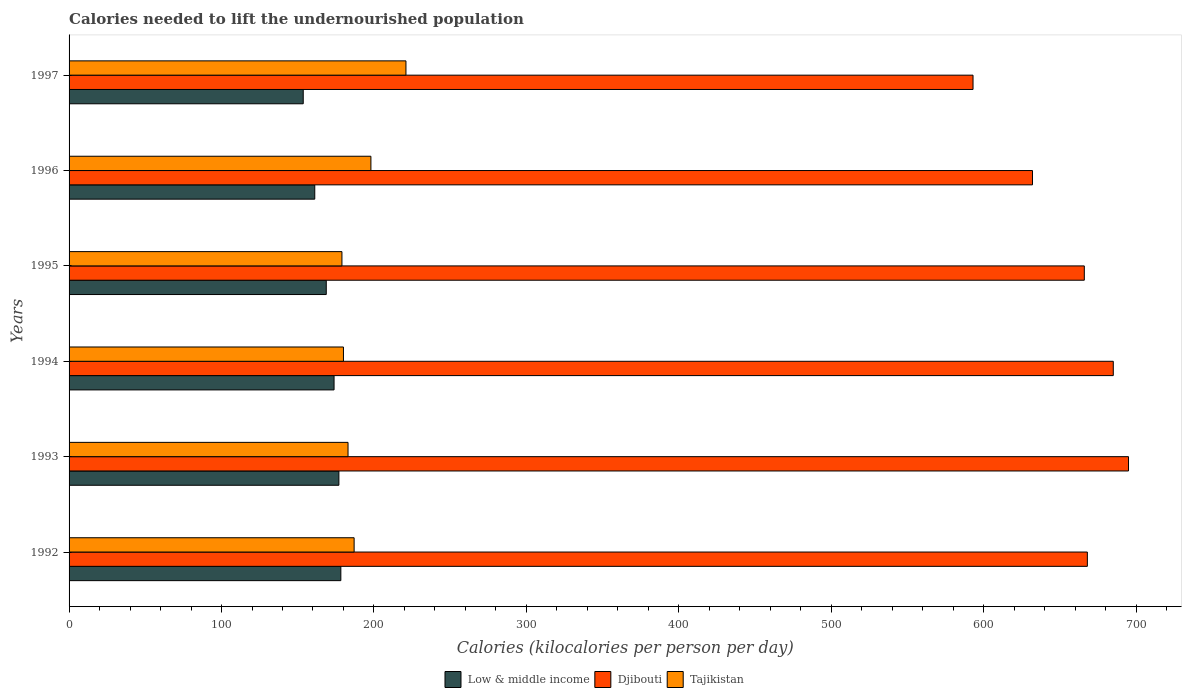How many different coloured bars are there?
Give a very brief answer. 3. How many groups of bars are there?
Your answer should be very brief. 6. What is the label of the 2nd group of bars from the top?
Provide a succinct answer. 1996. In how many cases, is the number of bars for a given year not equal to the number of legend labels?
Your response must be concise. 0. What is the total calories needed to lift the undernourished population in Low & middle income in 1995?
Keep it short and to the point. 168.72. Across all years, what is the maximum total calories needed to lift the undernourished population in Low & middle income?
Your answer should be very brief. 178.28. Across all years, what is the minimum total calories needed to lift the undernourished population in Low & middle income?
Make the answer very short. 153.61. In which year was the total calories needed to lift the undernourished population in Tajikistan minimum?
Offer a very short reply. 1995. What is the total total calories needed to lift the undernourished population in Djibouti in the graph?
Provide a succinct answer. 3939. What is the difference between the total calories needed to lift the undernourished population in Djibouti in 1992 and that in 1995?
Your answer should be compact. 2. What is the difference between the total calories needed to lift the undernourished population in Tajikistan in 1994 and the total calories needed to lift the undernourished population in Low & middle income in 1992?
Your answer should be very brief. 1.72. What is the average total calories needed to lift the undernourished population in Low & middle income per year?
Your answer should be very brief. 168.77. In the year 1996, what is the difference between the total calories needed to lift the undernourished population in Tajikistan and total calories needed to lift the undernourished population in Djibouti?
Make the answer very short. -434. In how many years, is the total calories needed to lift the undernourished population in Tajikistan greater than 500 kilocalories?
Give a very brief answer. 0. What is the ratio of the total calories needed to lift the undernourished population in Low & middle income in 1992 to that in 1993?
Keep it short and to the point. 1.01. Is the total calories needed to lift the undernourished population in Low & middle income in 1994 less than that in 1996?
Offer a very short reply. No. Is the difference between the total calories needed to lift the undernourished population in Tajikistan in 1994 and 1996 greater than the difference between the total calories needed to lift the undernourished population in Djibouti in 1994 and 1996?
Ensure brevity in your answer.  No. What is the difference between the highest and the lowest total calories needed to lift the undernourished population in Low & middle income?
Your answer should be compact. 24.67. What does the 1st bar from the top in 1994 represents?
Make the answer very short. Tajikistan. What does the 3rd bar from the bottom in 1996 represents?
Your answer should be compact. Tajikistan. Is it the case that in every year, the sum of the total calories needed to lift the undernourished population in Tajikistan and total calories needed to lift the undernourished population in Djibouti is greater than the total calories needed to lift the undernourished population in Low & middle income?
Offer a terse response. Yes. How many bars are there?
Offer a terse response. 18. Are all the bars in the graph horizontal?
Ensure brevity in your answer.  Yes. How many years are there in the graph?
Provide a succinct answer. 6. What is the difference between two consecutive major ticks on the X-axis?
Keep it short and to the point. 100. Are the values on the major ticks of X-axis written in scientific E-notation?
Keep it short and to the point. No. Does the graph contain any zero values?
Keep it short and to the point. No. Does the graph contain grids?
Offer a terse response. No. What is the title of the graph?
Offer a very short reply. Calories needed to lift the undernourished population. What is the label or title of the X-axis?
Your answer should be compact. Calories (kilocalories per person per day). What is the label or title of the Y-axis?
Your answer should be compact. Years. What is the Calories (kilocalories per person per day) of Low & middle income in 1992?
Keep it short and to the point. 178.28. What is the Calories (kilocalories per person per day) in Djibouti in 1992?
Your answer should be compact. 668. What is the Calories (kilocalories per person per day) in Tajikistan in 1992?
Your answer should be very brief. 187. What is the Calories (kilocalories per person per day) of Low & middle income in 1993?
Give a very brief answer. 177. What is the Calories (kilocalories per person per day) in Djibouti in 1993?
Keep it short and to the point. 695. What is the Calories (kilocalories per person per day) of Tajikistan in 1993?
Your answer should be very brief. 183. What is the Calories (kilocalories per person per day) of Low & middle income in 1994?
Offer a terse response. 173.84. What is the Calories (kilocalories per person per day) of Djibouti in 1994?
Your response must be concise. 685. What is the Calories (kilocalories per person per day) of Tajikistan in 1994?
Offer a terse response. 180. What is the Calories (kilocalories per person per day) in Low & middle income in 1995?
Make the answer very short. 168.72. What is the Calories (kilocalories per person per day) of Djibouti in 1995?
Your answer should be very brief. 666. What is the Calories (kilocalories per person per day) of Tajikistan in 1995?
Provide a succinct answer. 179. What is the Calories (kilocalories per person per day) of Low & middle income in 1996?
Ensure brevity in your answer.  161.17. What is the Calories (kilocalories per person per day) in Djibouti in 1996?
Your answer should be very brief. 632. What is the Calories (kilocalories per person per day) of Tajikistan in 1996?
Provide a succinct answer. 198. What is the Calories (kilocalories per person per day) of Low & middle income in 1997?
Your answer should be compact. 153.61. What is the Calories (kilocalories per person per day) in Djibouti in 1997?
Offer a very short reply. 593. What is the Calories (kilocalories per person per day) in Tajikistan in 1997?
Keep it short and to the point. 221. Across all years, what is the maximum Calories (kilocalories per person per day) of Low & middle income?
Your response must be concise. 178.28. Across all years, what is the maximum Calories (kilocalories per person per day) in Djibouti?
Offer a very short reply. 695. Across all years, what is the maximum Calories (kilocalories per person per day) in Tajikistan?
Keep it short and to the point. 221. Across all years, what is the minimum Calories (kilocalories per person per day) in Low & middle income?
Keep it short and to the point. 153.61. Across all years, what is the minimum Calories (kilocalories per person per day) of Djibouti?
Provide a short and direct response. 593. Across all years, what is the minimum Calories (kilocalories per person per day) of Tajikistan?
Your answer should be compact. 179. What is the total Calories (kilocalories per person per day) of Low & middle income in the graph?
Your answer should be compact. 1012.62. What is the total Calories (kilocalories per person per day) in Djibouti in the graph?
Keep it short and to the point. 3939. What is the total Calories (kilocalories per person per day) in Tajikistan in the graph?
Offer a very short reply. 1148. What is the difference between the Calories (kilocalories per person per day) of Low & middle income in 1992 and that in 1993?
Your answer should be compact. 1.28. What is the difference between the Calories (kilocalories per person per day) of Djibouti in 1992 and that in 1993?
Ensure brevity in your answer.  -27. What is the difference between the Calories (kilocalories per person per day) in Low & middle income in 1992 and that in 1994?
Provide a short and direct response. 4.44. What is the difference between the Calories (kilocalories per person per day) of Tajikistan in 1992 and that in 1994?
Provide a short and direct response. 7. What is the difference between the Calories (kilocalories per person per day) of Low & middle income in 1992 and that in 1995?
Keep it short and to the point. 9.56. What is the difference between the Calories (kilocalories per person per day) in Low & middle income in 1992 and that in 1996?
Offer a terse response. 17.11. What is the difference between the Calories (kilocalories per person per day) in Low & middle income in 1992 and that in 1997?
Ensure brevity in your answer.  24.67. What is the difference between the Calories (kilocalories per person per day) of Djibouti in 1992 and that in 1997?
Provide a succinct answer. 75. What is the difference between the Calories (kilocalories per person per day) in Tajikistan in 1992 and that in 1997?
Ensure brevity in your answer.  -34. What is the difference between the Calories (kilocalories per person per day) in Low & middle income in 1993 and that in 1994?
Your answer should be very brief. 3.16. What is the difference between the Calories (kilocalories per person per day) in Low & middle income in 1993 and that in 1995?
Provide a short and direct response. 8.28. What is the difference between the Calories (kilocalories per person per day) of Djibouti in 1993 and that in 1995?
Offer a terse response. 29. What is the difference between the Calories (kilocalories per person per day) of Tajikistan in 1993 and that in 1995?
Provide a short and direct response. 4. What is the difference between the Calories (kilocalories per person per day) of Low & middle income in 1993 and that in 1996?
Provide a short and direct response. 15.83. What is the difference between the Calories (kilocalories per person per day) of Tajikistan in 1993 and that in 1996?
Keep it short and to the point. -15. What is the difference between the Calories (kilocalories per person per day) in Low & middle income in 1993 and that in 1997?
Your answer should be very brief. 23.39. What is the difference between the Calories (kilocalories per person per day) in Djibouti in 1993 and that in 1997?
Your response must be concise. 102. What is the difference between the Calories (kilocalories per person per day) in Tajikistan in 1993 and that in 1997?
Your response must be concise. -38. What is the difference between the Calories (kilocalories per person per day) in Low & middle income in 1994 and that in 1995?
Offer a terse response. 5.12. What is the difference between the Calories (kilocalories per person per day) in Tajikistan in 1994 and that in 1995?
Keep it short and to the point. 1. What is the difference between the Calories (kilocalories per person per day) in Low & middle income in 1994 and that in 1996?
Provide a succinct answer. 12.66. What is the difference between the Calories (kilocalories per person per day) of Tajikistan in 1994 and that in 1996?
Ensure brevity in your answer.  -18. What is the difference between the Calories (kilocalories per person per day) in Low & middle income in 1994 and that in 1997?
Make the answer very short. 20.23. What is the difference between the Calories (kilocalories per person per day) of Djibouti in 1994 and that in 1997?
Keep it short and to the point. 92. What is the difference between the Calories (kilocalories per person per day) in Tajikistan in 1994 and that in 1997?
Provide a short and direct response. -41. What is the difference between the Calories (kilocalories per person per day) of Low & middle income in 1995 and that in 1996?
Offer a very short reply. 7.55. What is the difference between the Calories (kilocalories per person per day) in Djibouti in 1995 and that in 1996?
Keep it short and to the point. 34. What is the difference between the Calories (kilocalories per person per day) in Low & middle income in 1995 and that in 1997?
Ensure brevity in your answer.  15.11. What is the difference between the Calories (kilocalories per person per day) in Tajikistan in 1995 and that in 1997?
Offer a very short reply. -42. What is the difference between the Calories (kilocalories per person per day) of Low & middle income in 1996 and that in 1997?
Give a very brief answer. 7.57. What is the difference between the Calories (kilocalories per person per day) in Low & middle income in 1992 and the Calories (kilocalories per person per day) in Djibouti in 1993?
Offer a terse response. -516.72. What is the difference between the Calories (kilocalories per person per day) in Low & middle income in 1992 and the Calories (kilocalories per person per day) in Tajikistan in 1993?
Ensure brevity in your answer.  -4.72. What is the difference between the Calories (kilocalories per person per day) of Djibouti in 1992 and the Calories (kilocalories per person per day) of Tajikistan in 1993?
Your answer should be compact. 485. What is the difference between the Calories (kilocalories per person per day) in Low & middle income in 1992 and the Calories (kilocalories per person per day) in Djibouti in 1994?
Offer a very short reply. -506.72. What is the difference between the Calories (kilocalories per person per day) of Low & middle income in 1992 and the Calories (kilocalories per person per day) of Tajikistan in 1994?
Keep it short and to the point. -1.72. What is the difference between the Calories (kilocalories per person per day) of Djibouti in 1992 and the Calories (kilocalories per person per day) of Tajikistan in 1994?
Provide a short and direct response. 488. What is the difference between the Calories (kilocalories per person per day) in Low & middle income in 1992 and the Calories (kilocalories per person per day) in Djibouti in 1995?
Ensure brevity in your answer.  -487.72. What is the difference between the Calories (kilocalories per person per day) in Low & middle income in 1992 and the Calories (kilocalories per person per day) in Tajikistan in 1995?
Make the answer very short. -0.72. What is the difference between the Calories (kilocalories per person per day) in Djibouti in 1992 and the Calories (kilocalories per person per day) in Tajikistan in 1995?
Your answer should be very brief. 489. What is the difference between the Calories (kilocalories per person per day) in Low & middle income in 1992 and the Calories (kilocalories per person per day) in Djibouti in 1996?
Your response must be concise. -453.72. What is the difference between the Calories (kilocalories per person per day) of Low & middle income in 1992 and the Calories (kilocalories per person per day) of Tajikistan in 1996?
Ensure brevity in your answer.  -19.72. What is the difference between the Calories (kilocalories per person per day) in Djibouti in 1992 and the Calories (kilocalories per person per day) in Tajikistan in 1996?
Provide a succinct answer. 470. What is the difference between the Calories (kilocalories per person per day) in Low & middle income in 1992 and the Calories (kilocalories per person per day) in Djibouti in 1997?
Your response must be concise. -414.72. What is the difference between the Calories (kilocalories per person per day) in Low & middle income in 1992 and the Calories (kilocalories per person per day) in Tajikistan in 1997?
Give a very brief answer. -42.72. What is the difference between the Calories (kilocalories per person per day) in Djibouti in 1992 and the Calories (kilocalories per person per day) in Tajikistan in 1997?
Your answer should be very brief. 447. What is the difference between the Calories (kilocalories per person per day) in Low & middle income in 1993 and the Calories (kilocalories per person per day) in Djibouti in 1994?
Keep it short and to the point. -508. What is the difference between the Calories (kilocalories per person per day) of Low & middle income in 1993 and the Calories (kilocalories per person per day) of Tajikistan in 1994?
Provide a succinct answer. -3. What is the difference between the Calories (kilocalories per person per day) in Djibouti in 1993 and the Calories (kilocalories per person per day) in Tajikistan in 1994?
Make the answer very short. 515. What is the difference between the Calories (kilocalories per person per day) of Low & middle income in 1993 and the Calories (kilocalories per person per day) of Djibouti in 1995?
Your response must be concise. -489. What is the difference between the Calories (kilocalories per person per day) in Low & middle income in 1993 and the Calories (kilocalories per person per day) in Tajikistan in 1995?
Offer a terse response. -2. What is the difference between the Calories (kilocalories per person per day) in Djibouti in 1993 and the Calories (kilocalories per person per day) in Tajikistan in 1995?
Offer a very short reply. 516. What is the difference between the Calories (kilocalories per person per day) in Low & middle income in 1993 and the Calories (kilocalories per person per day) in Djibouti in 1996?
Your answer should be very brief. -455. What is the difference between the Calories (kilocalories per person per day) in Low & middle income in 1993 and the Calories (kilocalories per person per day) in Tajikistan in 1996?
Keep it short and to the point. -21. What is the difference between the Calories (kilocalories per person per day) in Djibouti in 1993 and the Calories (kilocalories per person per day) in Tajikistan in 1996?
Your response must be concise. 497. What is the difference between the Calories (kilocalories per person per day) of Low & middle income in 1993 and the Calories (kilocalories per person per day) of Djibouti in 1997?
Provide a short and direct response. -416. What is the difference between the Calories (kilocalories per person per day) in Low & middle income in 1993 and the Calories (kilocalories per person per day) in Tajikistan in 1997?
Offer a terse response. -44. What is the difference between the Calories (kilocalories per person per day) in Djibouti in 1993 and the Calories (kilocalories per person per day) in Tajikistan in 1997?
Your answer should be compact. 474. What is the difference between the Calories (kilocalories per person per day) of Low & middle income in 1994 and the Calories (kilocalories per person per day) of Djibouti in 1995?
Give a very brief answer. -492.16. What is the difference between the Calories (kilocalories per person per day) in Low & middle income in 1994 and the Calories (kilocalories per person per day) in Tajikistan in 1995?
Your answer should be very brief. -5.16. What is the difference between the Calories (kilocalories per person per day) in Djibouti in 1994 and the Calories (kilocalories per person per day) in Tajikistan in 1995?
Make the answer very short. 506. What is the difference between the Calories (kilocalories per person per day) of Low & middle income in 1994 and the Calories (kilocalories per person per day) of Djibouti in 1996?
Provide a succinct answer. -458.16. What is the difference between the Calories (kilocalories per person per day) of Low & middle income in 1994 and the Calories (kilocalories per person per day) of Tajikistan in 1996?
Your answer should be compact. -24.16. What is the difference between the Calories (kilocalories per person per day) of Djibouti in 1994 and the Calories (kilocalories per person per day) of Tajikistan in 1996?
Your response must be concise. 487. What is the difference between the Calories (kilocalories per person per day) of Low & middle income in 1994 and the Calories (kilocalories per person per day) of Djibouti in 1997?
Provide a succinct answer. -419.16. What is the difference between the Calories (kilocalories per person per day) of Low & middle income in 1994 and the Calories (kilocalories per person per day) of Tajikistan in 1997?
Offer a very short reply. -47.16. What is the difference between the Calories (kilocalories per person per day) in Djibouti in 1994 and the Calories (kilocalories per person per day) in Tajikistan in 1997?
Give a very brief answer. 464. What is the difference between the Calories (kilocalories per person per day) in Low & middle income in 1995 and the Calories (kilocalories per person per day) in Djibouti in 1996?
Provide a short and direct response. -463.28. What is the difference between the Calories (kilocalories per person per day) in Low & middle income in 1995 and the Calories (kilocalories per person per day) in Tajikistan in 1996?
Your answer should be very brief. -29.28. What is the difference between the Calories (kilocalories per person per day) of Djibouti in 1995 and the Calories (kilocalories per person per day) of Tajikistan in 1996?
Offer a very short reply. 468. What is the difference between the Calories (kilocalories per person per day) of Low & middle income in 1995 and the Calories (kilocalories per person per day) of Djibouti in 1997?
Your answer should be very brief. -424.28. What is the difference between the Calories (kilocalories per person per day) in Low & middle income in 1995 and the Calories (kilocalories per person per day) in Tajikistan in 1997?
Offer a terse response. -52.28. What is the difference between the Calories (kilocalories per person per day) in Djibouti in 1995 and the Calories (kilocalories per person per day) in Tajikistan in 1997?
Provide a short and direct response. 445. What is the difference between the Calories (kilocalories per person per day) of Low & middle income in 1996 and the Calories (kilocalories per person per day) of Djibouti in 1997?
Ensure brevity in your answer.  -431.83. What is the difference between the Calories (kilocalories per person per day) of Low & middle income in 1996 and the Calories (kilocalories per person per day) of Tajikistan in 1997?
Your response must be concise. -59.83. What is the difference between the Calories (kilocalories per person per day) of Djibouti in 1996 and the Calories (kilocalories per person per day) of Tajikistan in 1997?
Provide a short and direct response. 411. What is the average Calories (kilocalories per person per day) of Low & middle income per year?
Offer a very short reply. 168.77. What is the average Calories (kilocalories per person per day) of Djibouti per year?
Give a very brief answer. 656.5. What is the average Calories (kilocalories per person per day) in Tajikistan per year?
Offer a very short reply. 191.33. In the year 1992, what is the difference between the Calories (kilocalories per person per day) in Low & middle income and Calories (kilocalories per person per day) in Djibouti?
Make the answer very short. -489.72. In the year 1992, what is the difference between the Calories (kilocalories per person per day) in Low & middle income and Calories (kilocalories per person per day) in Tajikistan?
Your answer should be very brief. -8.72. In the year 1992, what is the difference between the Calories (kilocalories per person per day) of Djibouti and Calories (kilocalories per person per day) of Tajikistan?
Offer a very short reply. 481. In the year 1993, what is the difference between the Calories (kilocalories per person per day) in Low & middle income and Calories (kilocalories per person per day) in Djibouti?
Your response must be concise. -518. In the year 1993, what is the difference between the Calories (kilocalories per person per day) of Low & middle income and Calories (kilocalories per person per day) of Tajikistan?
Offer a very short reply. -6. In the year 1993, what is the difference between the Calories (kilocalories per person per day) of Djibouti and Calories (kilocalories per person per day) of Tajikistan?
Offer a very short reply. 512. In the year 1994, what is the difference between the Calories (kilocalories per person per day) of Low & middle income and Calories (kilocalories per person per day) of Djibouti?
Keep it short and to the point. -511.16. In the year 1994, what is the difference between the Calories (kilocalories per person per day) of Low & middle income and Calories (kilocalories per person per day) of Tajikistan?
Offer a very short reply. -6.16. In the year 1994, what is the difference between the Calories (kilocalories per person per day) of Djibouti and Calories (kilocalories per person per day) of Tajikistan?
Provide a succinct answer. 505. In the year 1995, what is the difference between the Calories (kilocalories per person per day) in Low & middle income and Calories (kilocalories per person per day) in Djibouti?
Make the answer very short. -497.28. In the year 1995, what is the difference between the Calories (kilocalories per person per day) in Low & middle income and Calories (kilocalories per person per day) in Tajikistan?
Provide a succinct answer. -10.28. In the year 1995, what is the difference between the Calories (kilocalories per person per day) in Djibouti and Calories (kilocalories per person per day) in Tajikistan?
Your answer should be very brief. 487. In the year 1996, what is the difference between the Calories (kilocalories per person per day) in Low & middle income and Calories (kilocalories per person per day) in Djibouti?
Your answer should be very brief. -470.83. In the year 1996, what is the difference between the Calories (kilocalories per person per day) of Low & middle income and Calories (kilocalories per person per day) of Tajikistan?
Keep it short and to the point. -36.83. In the year 1996, what is the difference between the Calories (kilocalories per person per day) in Djibouti and Calories (kilocalories per person per day) in Tajikistan?
Provide a succinct answer. 434. In the year 1997, what is the difference between the Calories (kilocalories per person per day) of Low & middle income and Calories (kilocalories per person per day) of Djibouti?
Provide a succinct answer. -439.39. In the year 1997, what is the difference between the Calories (kilocalories per person per day) in Low & middle income and Calories (kilocalories per person per day) in Tajikistan?
Keep it short and to the point. -67.39. In the year 1997, what is the difference between the Calories (kilocalories per person per day) of Djibouti and Calories (kilocalories per person per day) of Tajikistan?
Your response must be concise. 372. What is the ratio of the Calories (kilocalories per person per day) in Low & middle income in 1992 to that in 1993?
Offer a terse response. 1.01. What is the ratio of the Calories (kilocalories per person per day) of Djibouti in 1992 to that in 1993?
Ensure brevity in your answer.  0.96. What is the ratio of the Calories (kilocalories per person per day) of Tajikistan in 1992 to that in 1993?
Offer a very short reply. 1.02. What is the ratio of the Calories (kilocalories per person per day) in Low & middle income in 1992 to that in 1994?
Offer a very short reply. 1.03. What is the ratio of the Calories (kilocalories per person per day) of Djibouti in 1992 to that in 1994?
Your answer should be compact. 0.98. What is the ratio of the Calories (kilocalories per person per day) of Tajikistan in 1992 to that in 1994?
Make the answer very short. 1.04. What is the ratio of the Calories (kilocalories per person per day) of Low & middle income in 1992 to that in 1995?
Provide a succinct answer. 1.06. What is the ratio of the Calories (kilocalories per person per day) in Djibouti in 1992 to that in 1995?
Make the answer very short. 1. What is the ratio of the Calories (kilocalories per person per day) in Tajikistan in 1992 to that in 1995?
Your answer should be very brief. 1.04. What is the ratio of the Calories (kilocalories per person per day) in Low & middle income in 1992 to that in 1996?
Offer a very short reply. 1.11. What is the ratio of the Calories (kilocalories per person per day) of Djibouti in 1992 to that in 1996?
Provide a succinct answer. 1.06. What is the ratio of the Calories (kilocalories per person per day) of Low & middle income in 1992 to that in 1997?
Your response must be concise. 1.16. What is the ratio of the Calories (kilocalories per person per day) in Djibouti in 1992 to that in 1997?
Your response must be concise. 1.13. What is the ratio of the Calories (kilocalories per person per day) in Tajikistan in 1992 to that in 1997?
Your answer should be compact. 0.85. What is the ratio of the Calories (kilocalories per person per day) in Low & middle income in 1993 to that in 1994?
Provide a succinct answer. 1.02. What is the ratio of the Calories (kilocalories per person per day) in Djibouti in 1993 to that in 1994?
Give a very brief answer. 1.01. What is the ratio of the Calories (kilocalories per person per day) of Tajikistan in 1993 to that in 1994?
Offer a terse response. 1.02. What is the ratio of the Calories (kilocalories per person per day) in Low & middle income in 1993 to that in 1995?
Your response must be concise. 1.05. What is the ratio of the Calories (kilocalories per person per day) in Djibouti in 1993 to that in 1995?
Give a very brief answer. 1.04. What is the ratio of the Calories (kilocalories per person per day) of Tajikistan in 1993 to that in 1995?
Provide a short and direct response. 1.02. What is the ratio of the Calories (kilocalories per person per day) in Low & middle income in 1993 to that in 1996?
Keep it short and to the point. 1.1. What is the ratio of the Calories (kilocalories per person per day) in Djibouti in 1993 to that in 1996?
Give a very brief answer. 1.1. What is the ratio of the Calories (kilocalories per person per day) of Tajikistan in 1993 to that in 1996?
Make the answer very short. 0.92. What is the ratio of the Calories (kilocalories per person per day) of Low & middle income in 1993 to that in 1997?
Offer a very short reply. 1.15. What is the ratio of the Calories (kilocalories per person per day) in Djibouti in 1993 to that in 1997?
Your answer should be very brief. 1.17. What is the ratio of the Calories (kilocalories per person per day) of Tajikistan in 1993 to that in 1997?
Give a very brief answer. 0.83. What is the ratio of the Calories (kilocalories per person per day) of Low & middle income in 1994 to that in 1995?
Give a very brief answer. 1.03. What is the ratio of the Calories (kilocalories per person per day) in Djibouti in 1994 to that in 1995?
Give a very brief answer. 1.03. What is the ratio of the Calories (kilocalories per person per day) of Tajikistan in 1994 to that in 1995?
Provide a succinct answer. 1.01. What is the ratio of the Calories (kilocalories per person per day) of Low & middle income in 1994 to that in 1996?
Provide a succinct answer. 1.08. What is the ratio of the Calories (kilocalories per person per day) in Djibouti in 1994 to that in 1996?
Make the answer very short. 1.08. What is the ratio of the Calories (kilocalories per person per day) of Tajikistan in 1994 to that in 1996?
Offer a terse response. 0.91. What is the ratio of the Calories (kilocalories per person per day) of Low & middle income in 1994 to that in 1997?
Give a very brief answer. 1.13. What is the ratio of the Calories (kilocalories per person per day) in Djibouti in 1994 to that in 1997?
Provide a succinct answer. 1.16. What is the ratio of the Calories (kilocalories per person per day) of Tajikistan in 1994 to that in 1997?
Your response must be concise. 0.81. What is the ratio of the Calories (kilocalories per person per day) in Low & middle income in 1995 to that in 1996?
Ensure brevity in your answer.  1.05. What is the ratio of the Calories (kilocalories per person per day) of Djibouti in 1995 to that in 1996?
Offer a very short reply. 1.05. What is the ratio of the Calories (kilocalories per person per day) of Tajikistan in 1995 to that in 1996?
Provide a short and direct response. 0.9. What is the ratio of the Calories (kilocalories per person per day) in Low & middle income in 1995 to that in 1997?
Make the answer very short. 1.1. What is the ratio of the Calories (kilocalories per person per day) in Djibouti in 1995 to that in 1997?
Provide a succinct answer. 1.12. What is the ratio of the Calories (kilocalories per person per day) of Tajikistan in 1995 to that in 1997?
Provide a short and direct response. 0.81. What is the ratio of the Calories (kilocalories per person per day) of Low & middle income in 1996 to that in 1997?
Ensure brevity in your answer.  1.05. What is the ratio of the Calories (kilocalories per person per day) in Djibouti in 1996 to that in 1997?
Offer a terse response. 1.07. What is the ratio of the Calories (kilocalories per person per day) of Tajikistan in 1996 to that in 1997?
Provide a succinct answer. 0.9. What is the difference between the highest and the second highest Calories (kilocalories per person per day) of Low & middle income?
Provide a short and direct response. 1.28. What is the difference between the highest and the second highest Calories (kilocalories per person per day) in Djibouti?
Provide a short and direct response. 10. What is the difference between the highest and the lowest Calories (kilocalories per person per day) in Low & middle income?
Your answer should be very brief. 24.67. What is the difference between the highest and the lowest Calories (kilocalories per person per day) of Djibouti?
Offer a terse response. 102. What is the difference between the highest and the lowest Calories (kilocalories per person per day) of Tajikistan?
Offer a terse response. 42. 